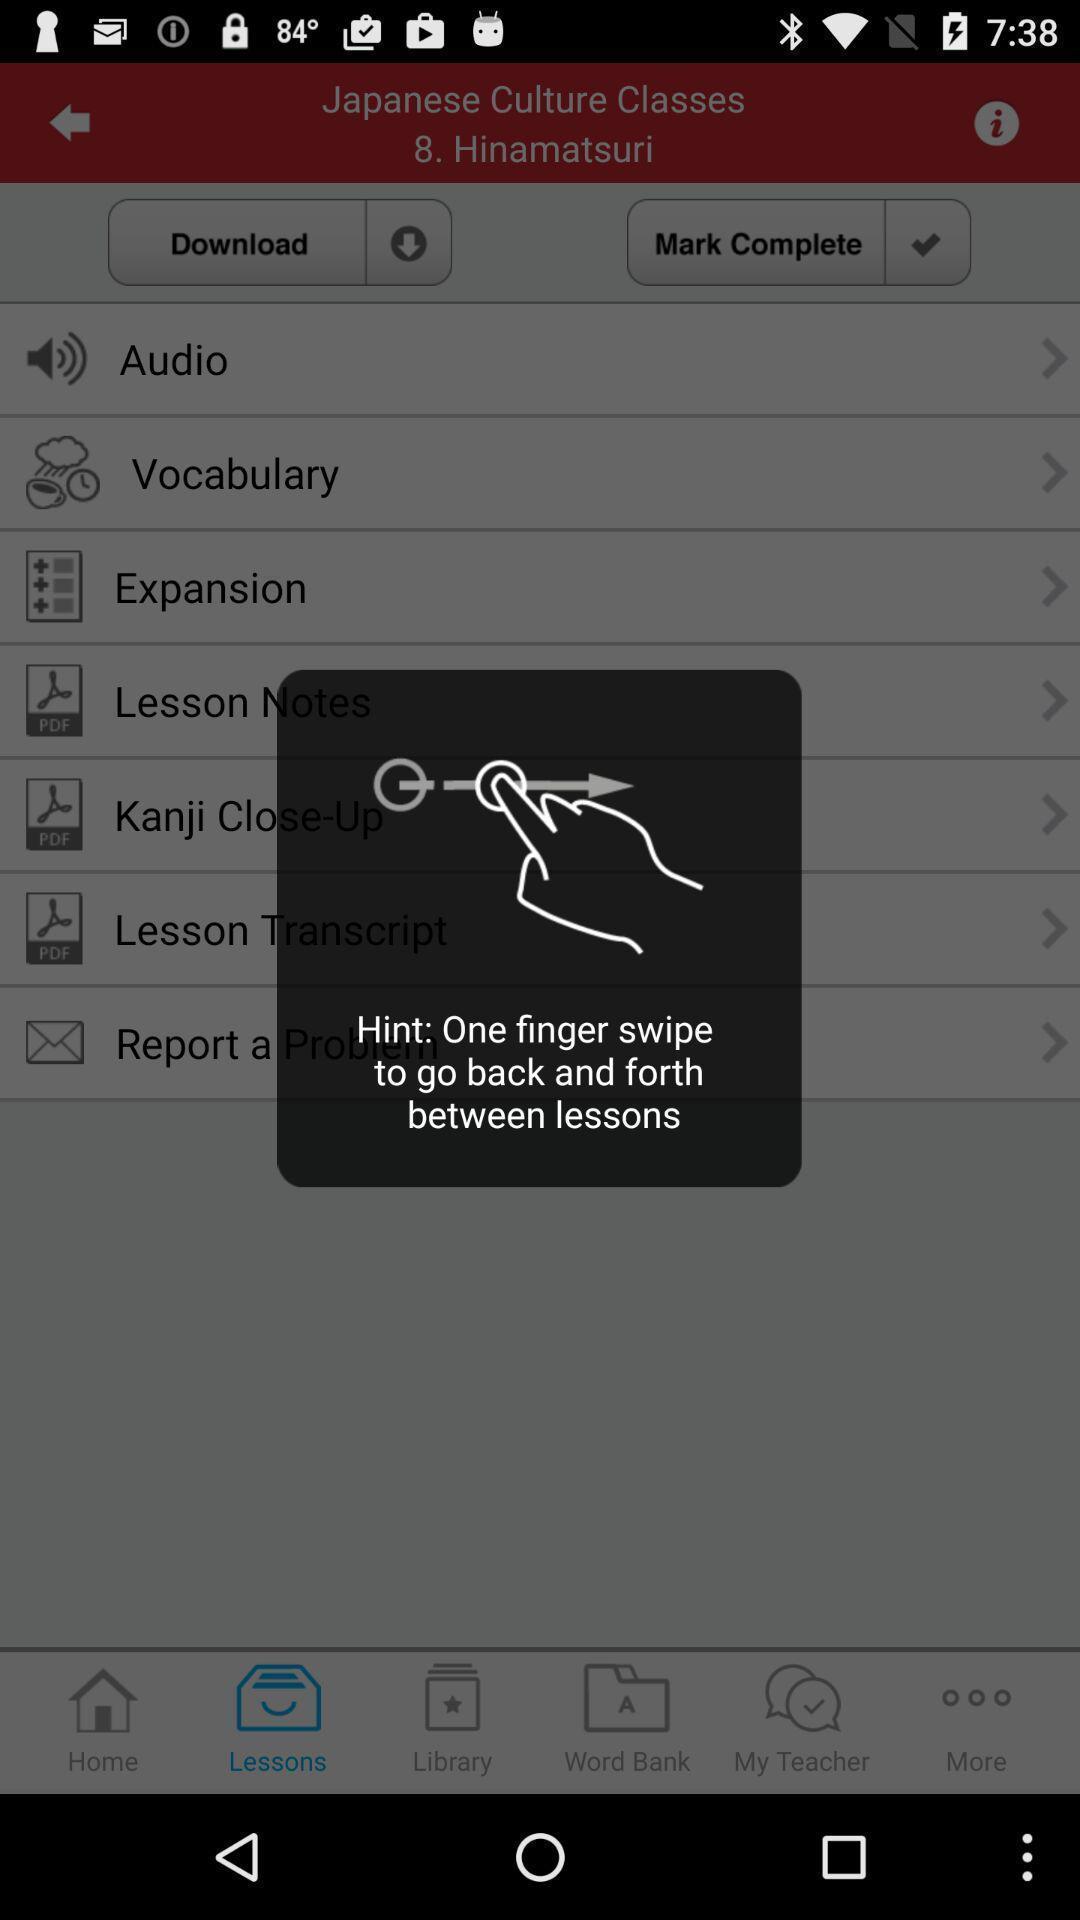Explain the elements present in this screenshot. Pop-up for hint to one finger swipe on language app. 